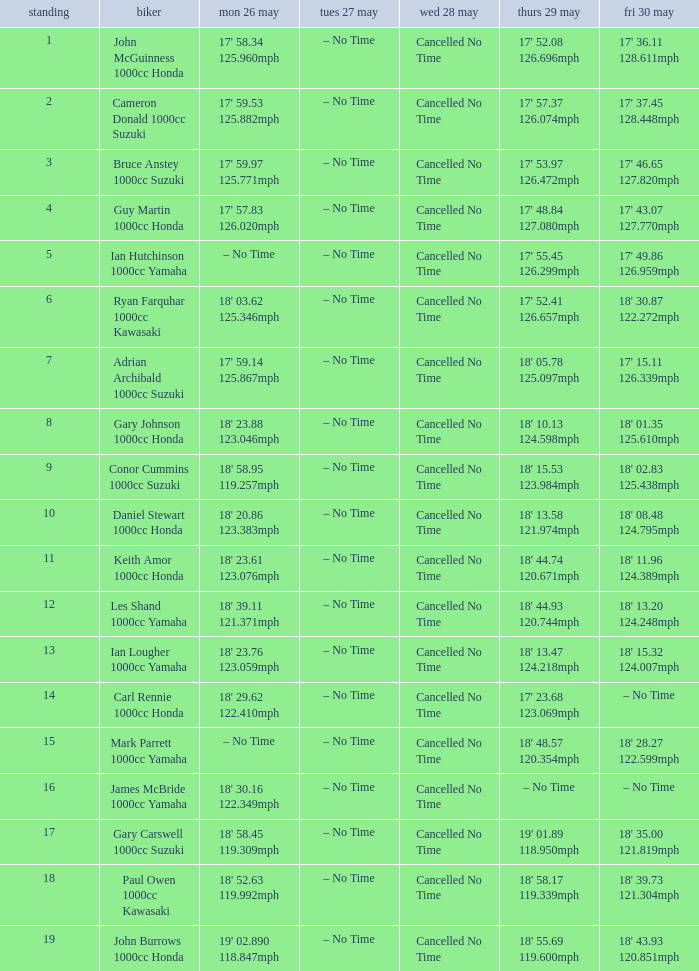What time is mon may 26 and fri may 30 is 18' 28.27 122.599mph? – No Time. 